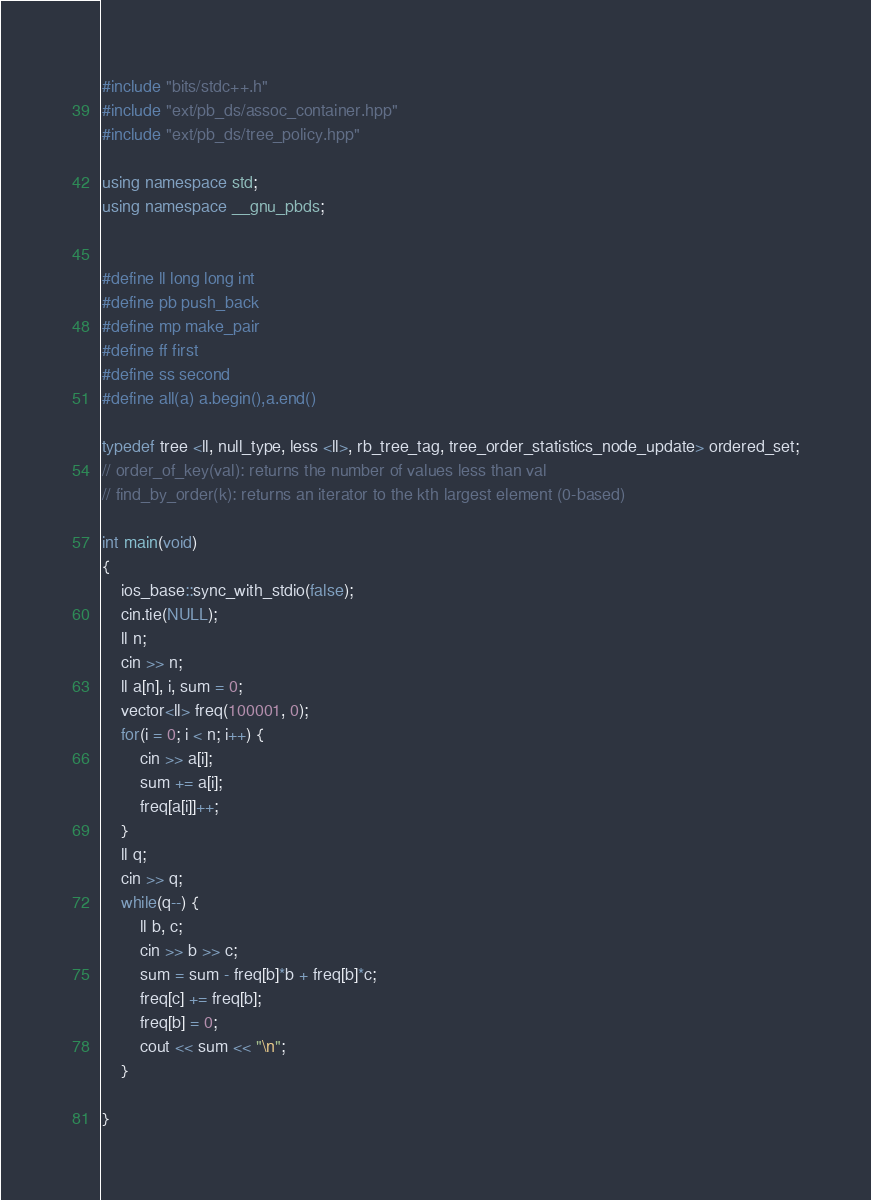<code> <loc_0><loc_0><loc_500><loc_500><_C++_>#include "bits/stdc++.h"
#include "ext/pb_ds/assoc_container.hpp"
#include "ext/pb_ds/tree_policy.hpp"

using namespace std;
using namespace __gnu_pbds;


#define ll long long int
#define pb push_back
#define mp make_pair
#define ff first
#define ss second
#define all(a) a.begin(),a.end()

typedef tree <ll, null_type, less <ll>, rb_tree_tag, tree_order_statistics_node_update> ordered_set;
// order_of_key(val): returns the number of values less than val
// find_by_order(k): returns an iterator to the kth largest element (0-based)

int main(void)
{
	ios_base::sync_with_stdio(false);
    cin.tie(NULL);
    ll n;
    cin >> n;
    ll a[n], i, sum = 0;
    vector<ll> freq(100001, 0);
    for(i = 0; i < n; i++) {
    	cin >> a[i];
    	sum += a[i];
    	freq[a[i]]++;
    }
    ll q;
    cin >> q;
    while(q--) {
    	ll b, c;
    	cin >> b >> c;
    	sum = sum - freq[b]*b + freq[b]*c;
    	freq[c] += freq[b];
    	freq[b] = 0;
    	cout << sum << "\n";
    }

}</code> 